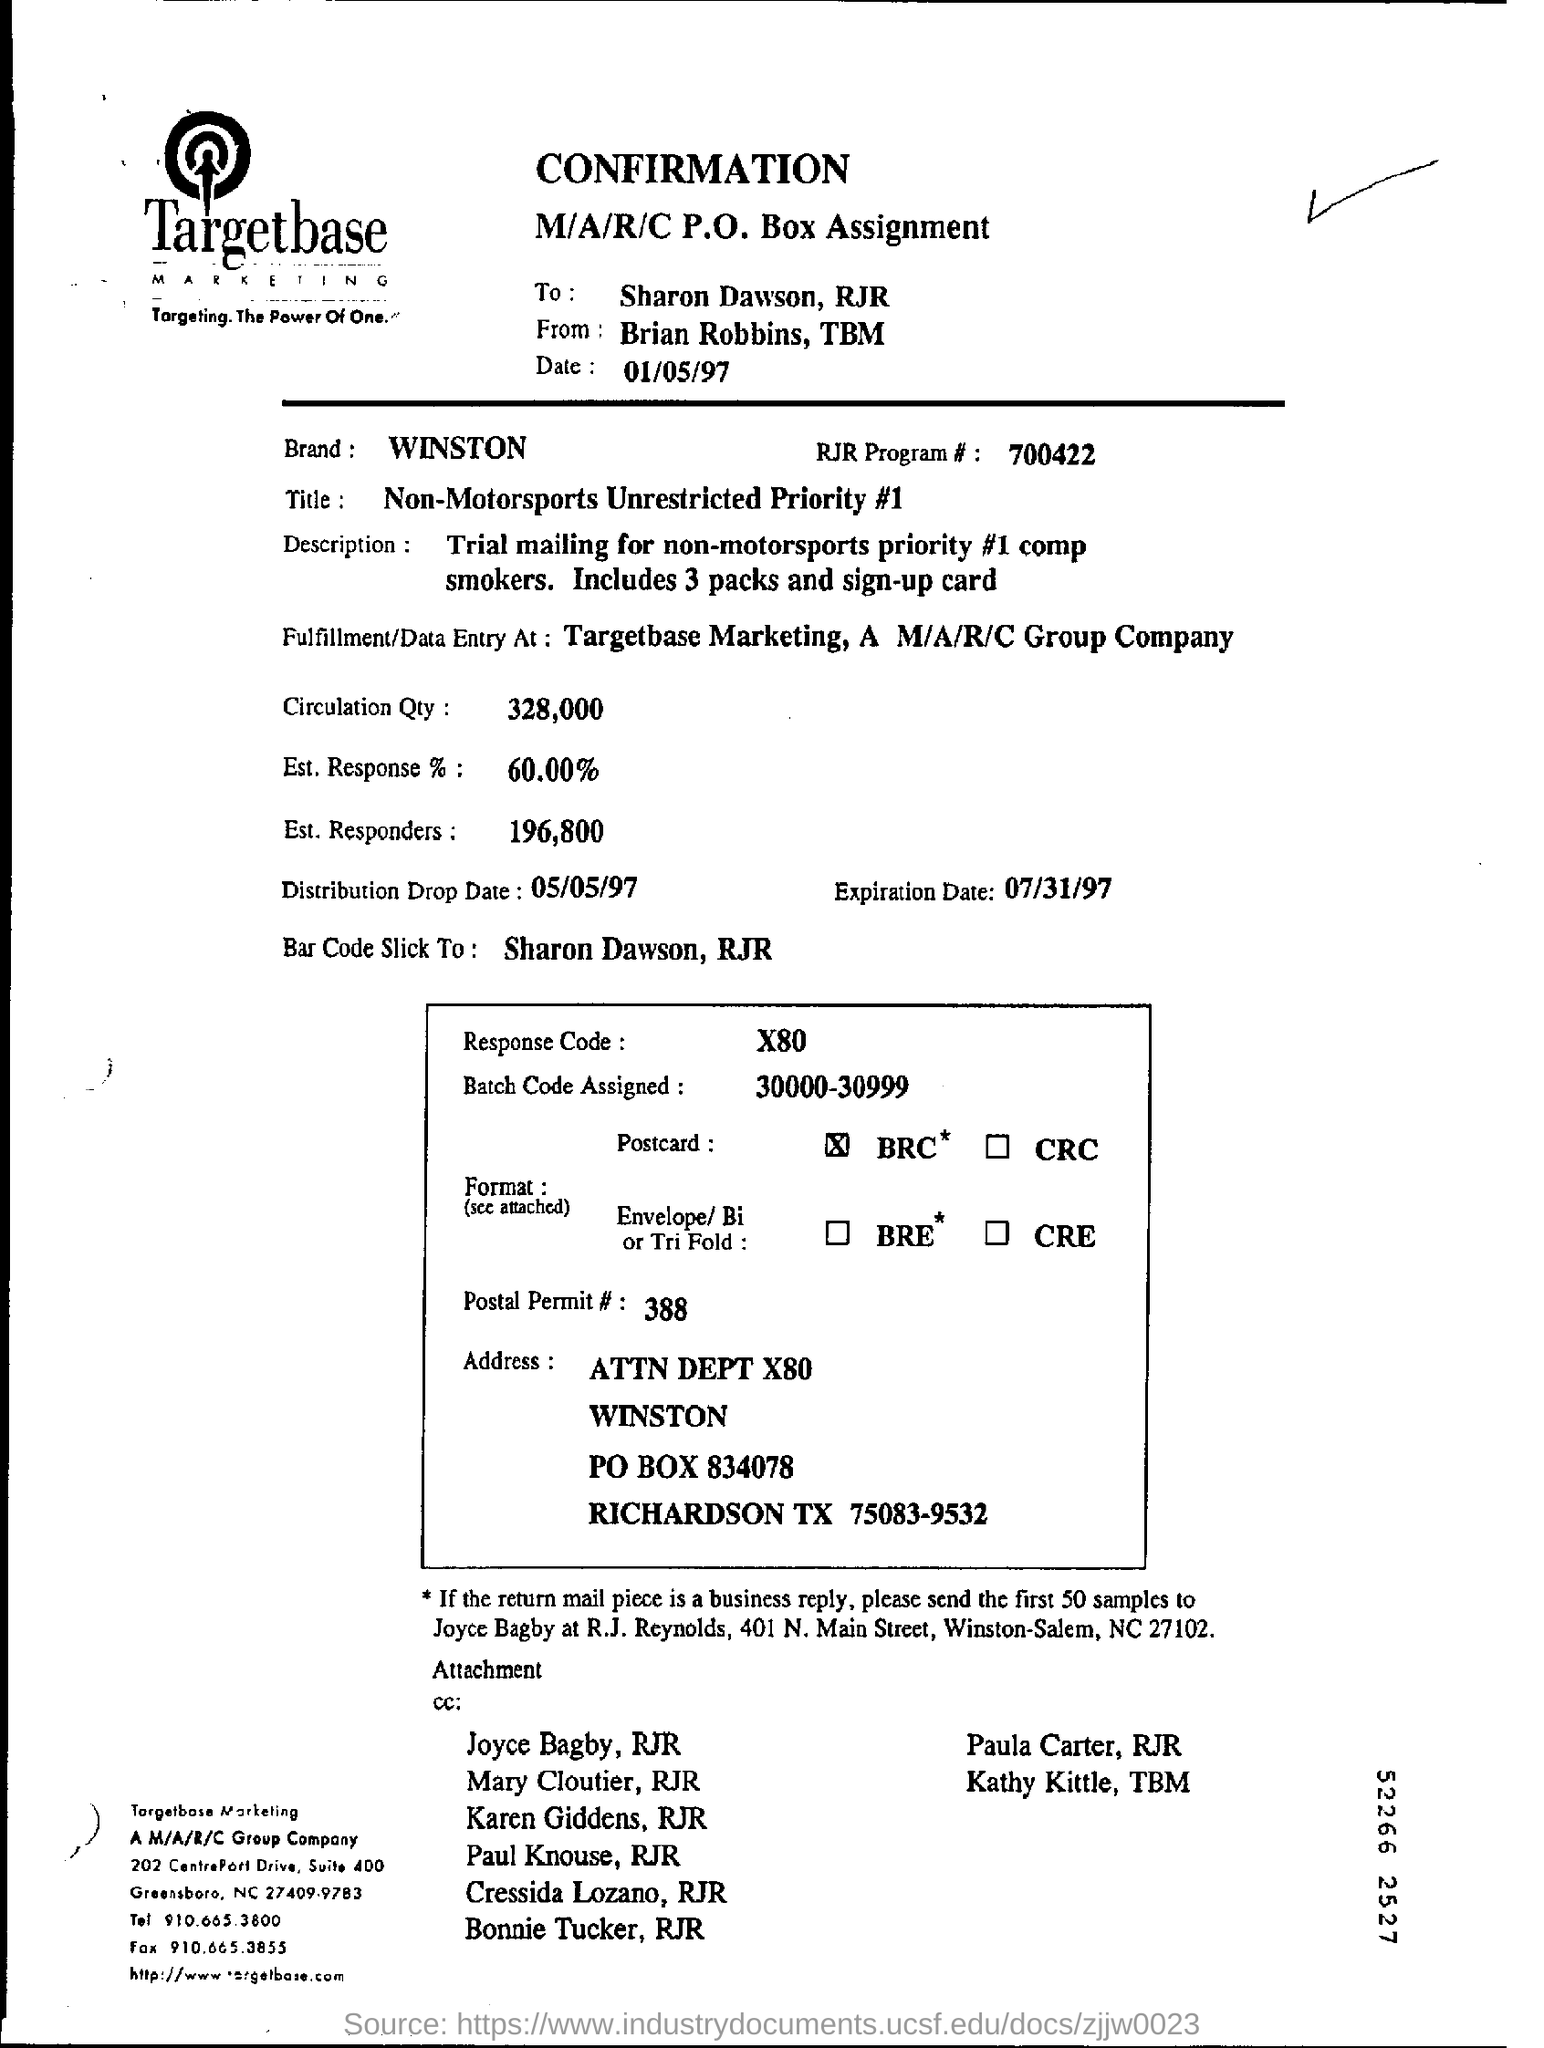What is the percentage of Est response?
Give a very brief answer. 60.00. What is the expiration date?
Keep it short and to the point. 07/31/97. 